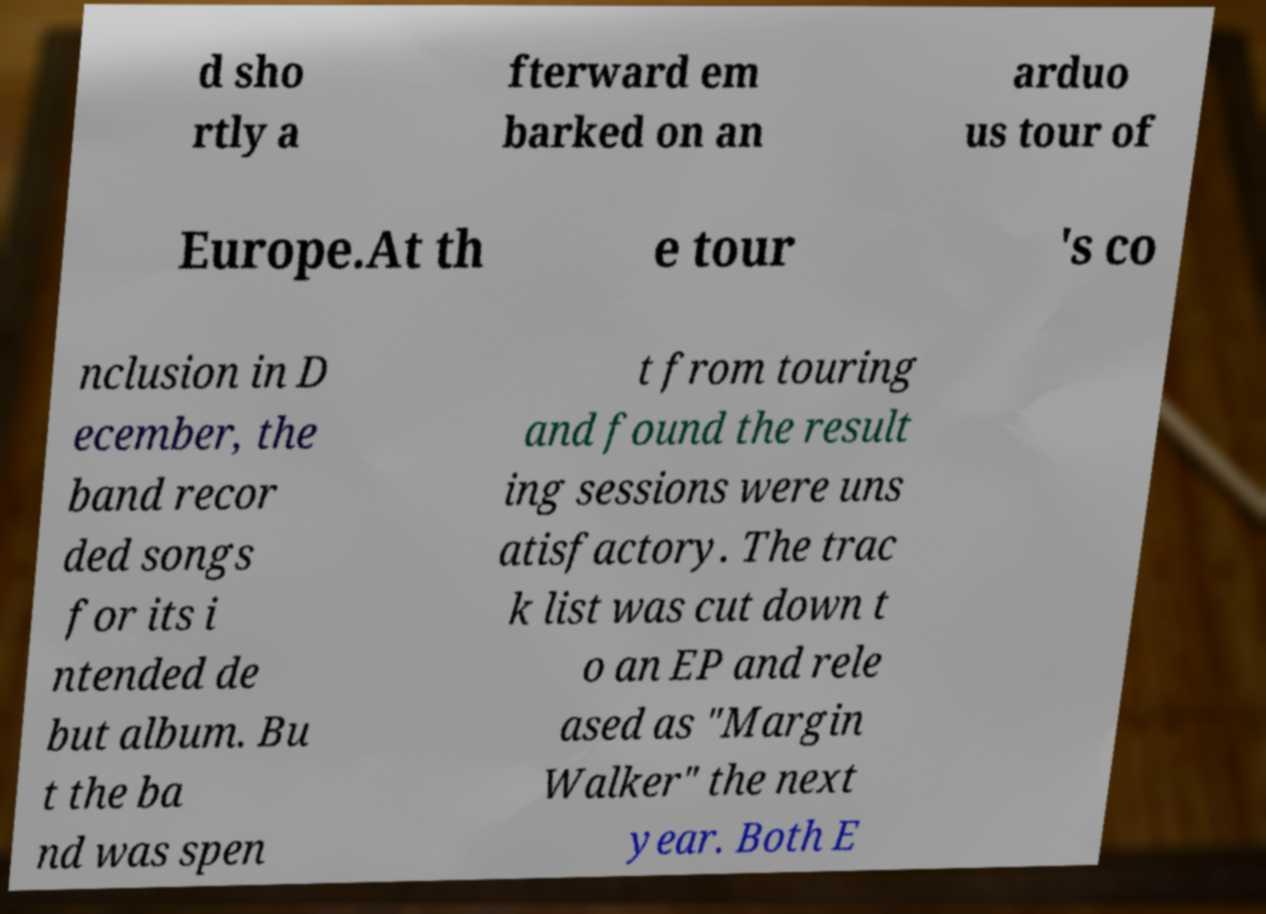Could you assist in decoding the text presented in this image and type it out clearly? d sho rtly a fterward em barked on an arduo us tour of Europe.At th e tour 's co nclusion in D ecember, the band recor ded songs for its i ntended de but album. Bu t the ba nd was spen t from touring and found the result ing sessions were uns atisfactory. The trac k list was cut down t o an EP and rele ased as "Margin Walker" the next year. Both E 